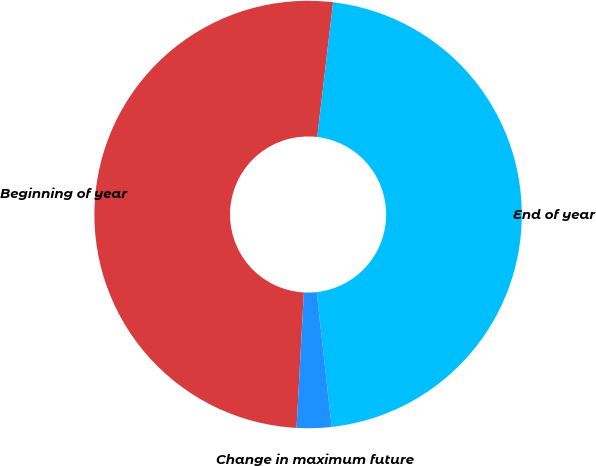Convert chart. <chart><loc_0><loc_0><loc_500><loc_500><pie_chart><fcel>Beginning of year<fcel>End of year<fcel>Change in maximum future<nl><fcel>51.01%<fcel>46.37%<fcel>2.62%<nl></chart> 